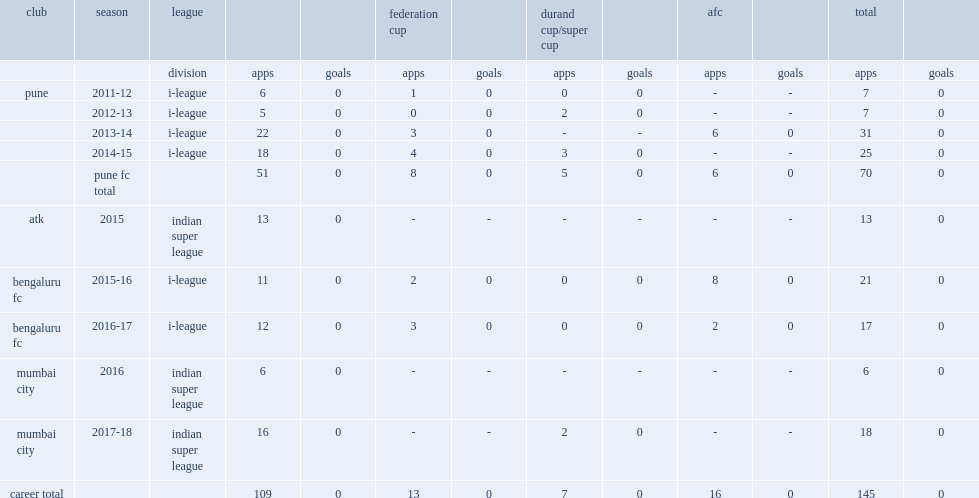In 2013-2014, which league did amrinder play for pune? I-league. 